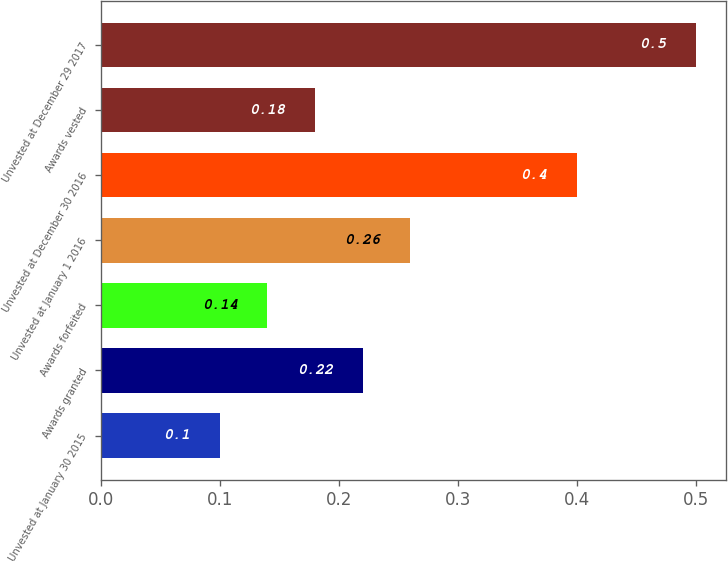Convert chart. <chart><loc_0><loc_0><loc_500><loc_500><bar_chart><fcel>Unvested at January 30 2015<fcel>Awards granted<fcel>Awards forfeited<fcel>Unvested at January 1 2016<fcel>Unvested at December 30 2016<fcel>Awards vested<fcel>Unvested at December 29 2017<nl><fcel>0.1<fcel>0.22<fcel>0.14<fcel>0.26<fcel>0.4<fcel>0.18<fcel>0.5<nl></chart> 